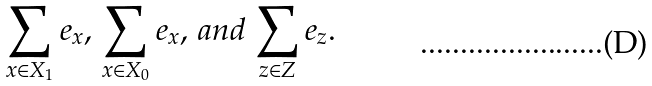<formula> <loc_0><loc_0><loc_500><loc_500>\sum _ { x \in X _ { 1 } } e _ { x } , \, \sum _ { x \in X _ { 0 } } e _ { x } , \, a n d \, \sum _ { z \in Z } e _ { z } .</formula> 